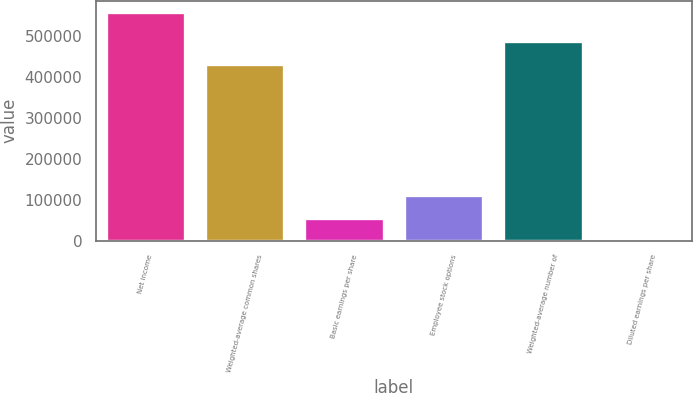Convert chart to OTSL. <chart><loc_0><loc_0><loc_500><loc_500><bar_chart><fcel>Net income<fcel>Weighted-average common shares<fcel>Basic earnings per share<fcel>Employee stock options<fcel>Weighted-average number of<fcel>Diluted earnings per share<nl><fcel>558929<fcel>431885<fcel>55894<fcel>111787<fcel>487778<fcel>1.25<nl></chart> 